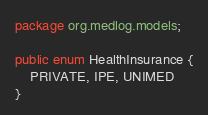Convert code to text. <code><loc_0><loc_0><loc_500><loc_500><_Java_>package org.medlog.models;

public enum HealthInsurance {
    PRIVATE, IPE, UNIMED
}
</code> 